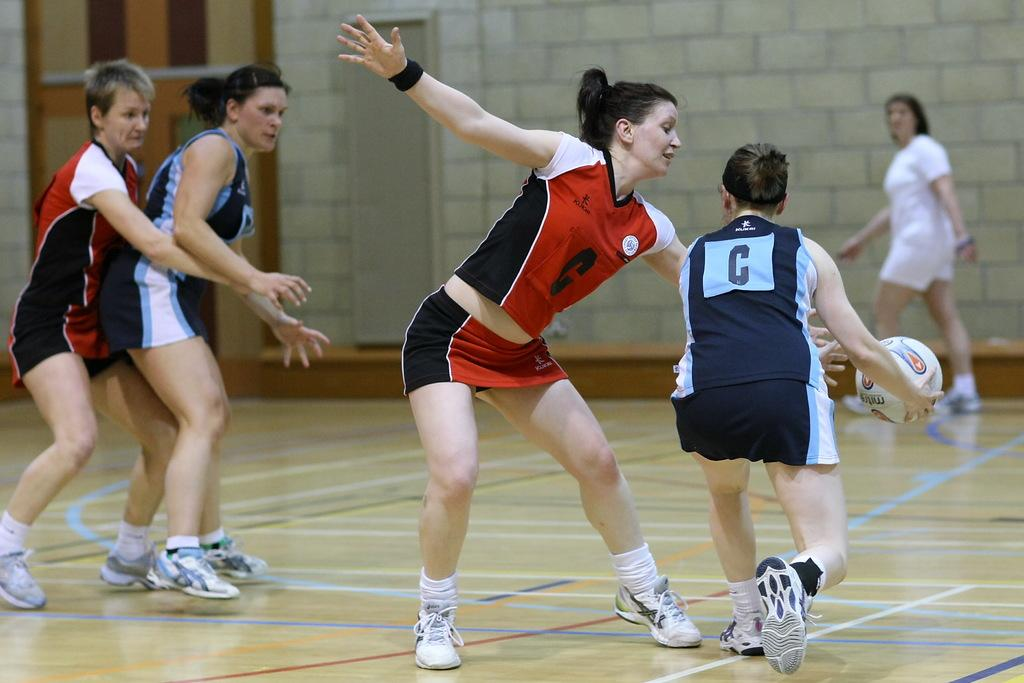<image>
Offer a succinct explanation of the picture presented. A female athlete wearing red, with the letter C on the front, is trying to block another female athlete, with a ball, from getting past her. 